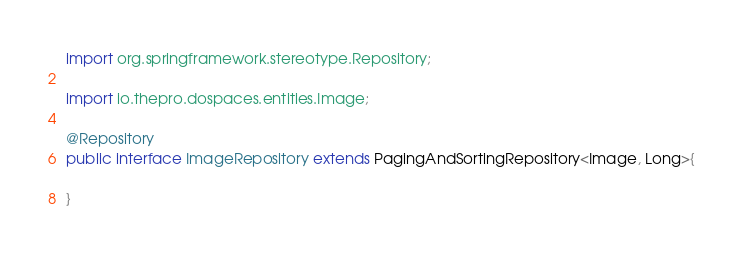<code> <loc_0><loc_0><loc_500><loc_500><_Java_>import org.springframework.stereotype.Repository;

import io.thepro.dospaces.entities.Image;

@Repository
public interface ImageRepository extends PagingAndSortingRepository<Image, Long>{

}
</code> 